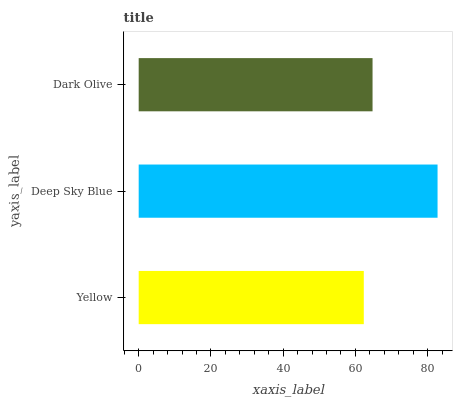Is Yellow the minimum?
Answer yes or no. Yes. Is Deep Sky Blue the maximum?
Answer yes or no. Yes. Is Dark Olive the minimum?
Answer yes or no. No. Is Dark Olive the maximum?
Answer yes or no. No. Is Deep Sky Blue greater than Dark Olive?
Answer yes or no. Yes. Is Dark Olive less than Deep Sky Blue?
Answer yes or no. Yes. Is Dark Olive greater than Deep Sky Blue?
Answer yes or no. No. Is Deep Sky Blue less than Dark Olive?
Answer yes or no. No. Is Dark Olive the high median?
Answer yes or no. Yes. Is Dark Olive the low median?
Answer yes or no. Yes. Is Yellow the high median?
Answer yes or no. No. Is Yellow the low median?
Answer yes or no. No. 